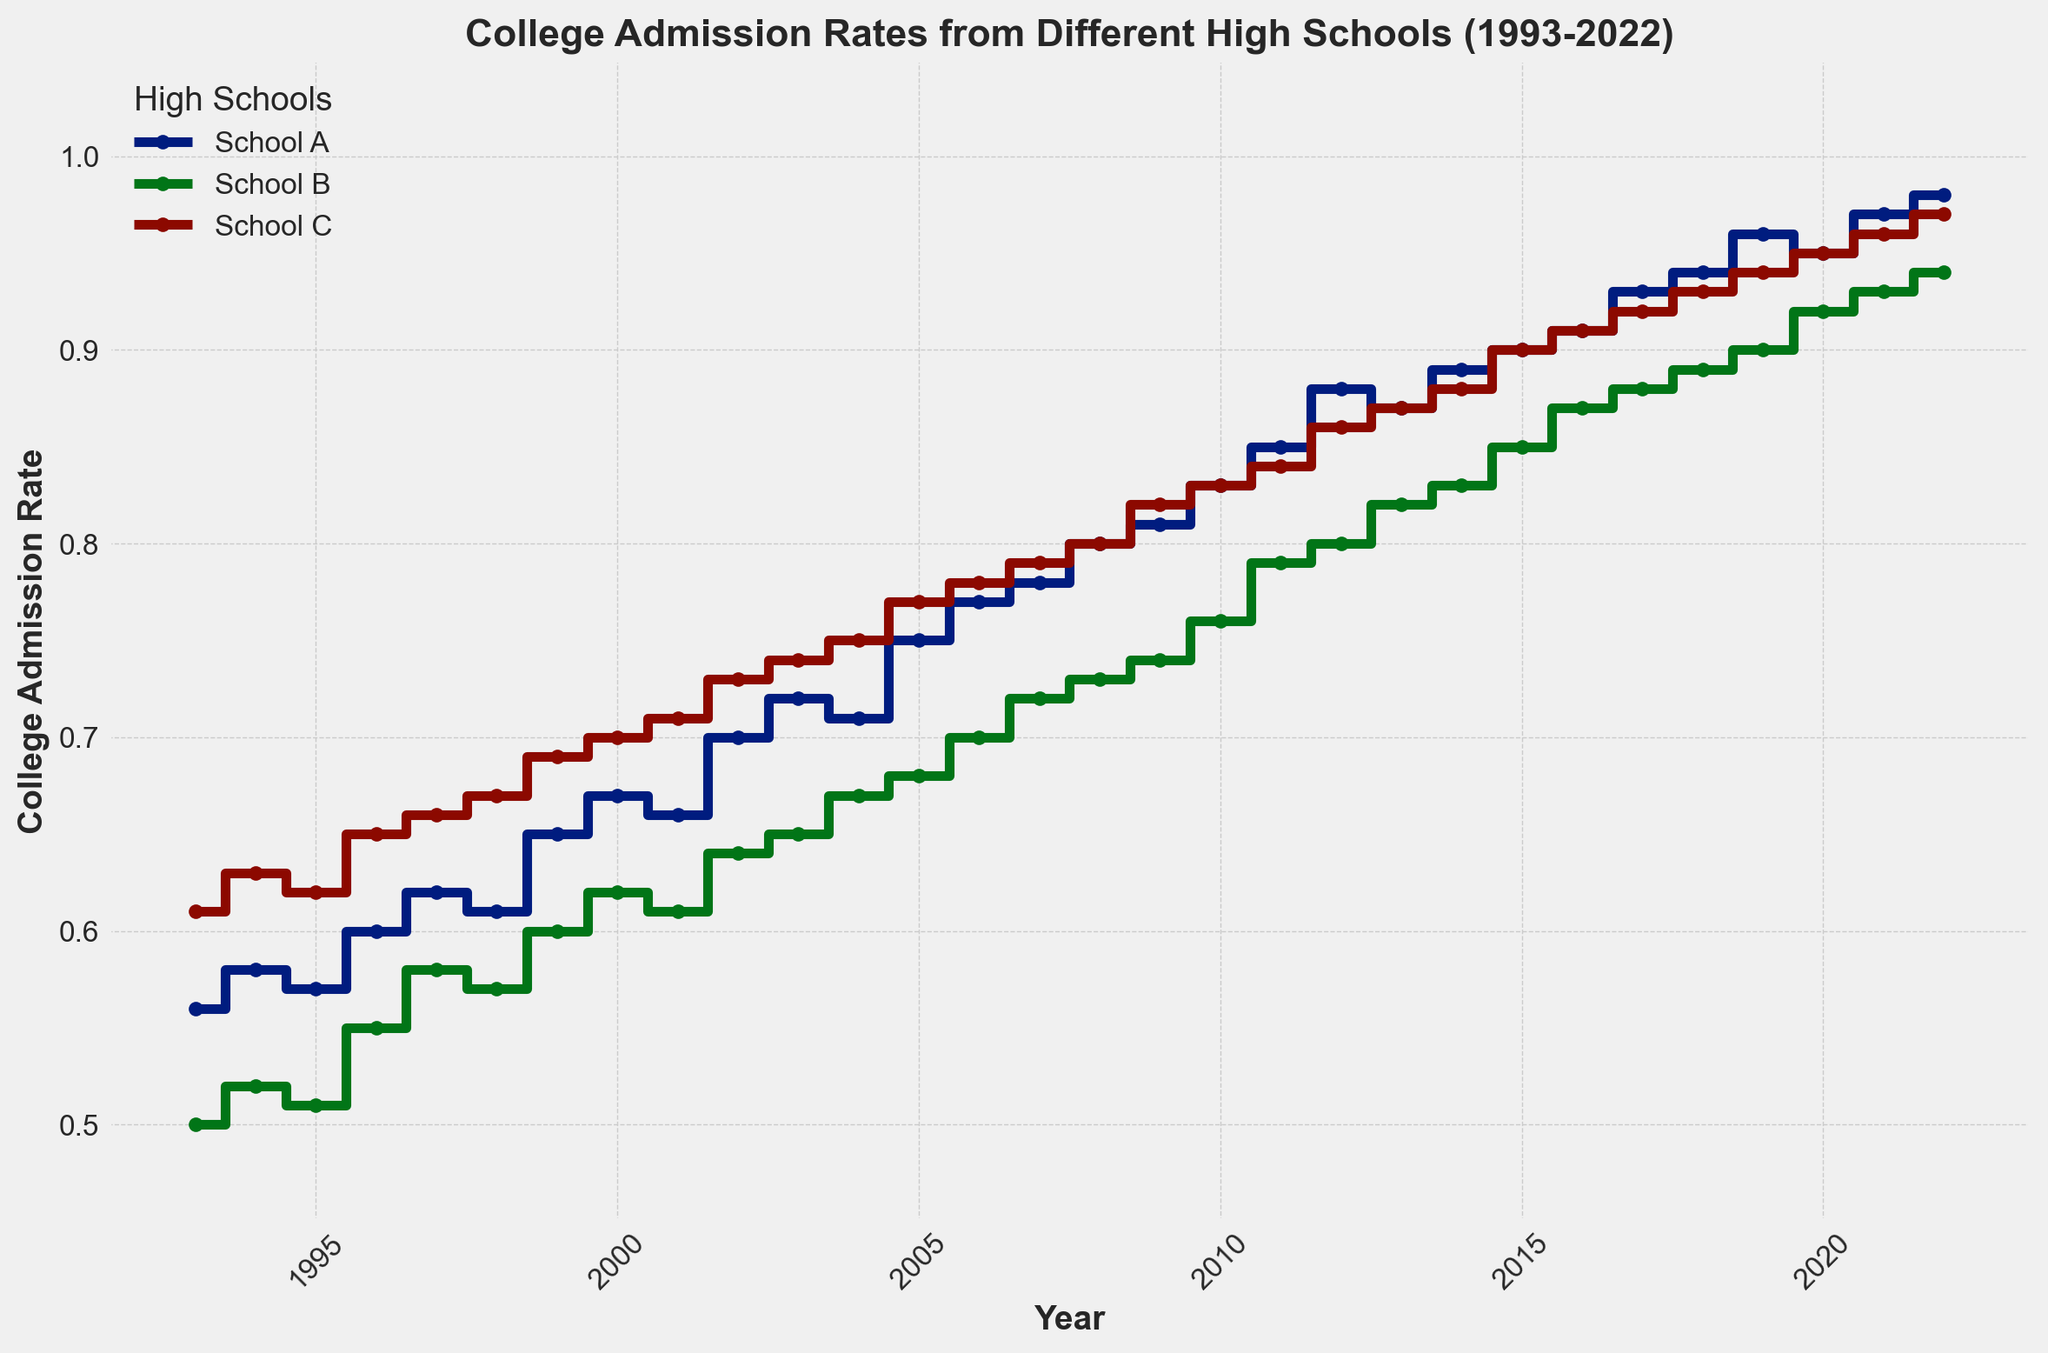What is the trend in college admission rates for High School A from 1993 to 2022? The figure shows a clear upward trend for High School A's college admission rates from 1993 to 2022, starting around 0.56 and rising to 0.98. The plot indicates a consistent increase over the years with some slight fluctuations.
Answer: Upward trend Which high school had the highest college admission rate in 2022? According to the figure, High School A had the highest college admission rate in 2022, reaching 0.98.
Answer: High School A By how much did the college admission rate for High School B increase from 1993 to 2022? To find the increase, subtract the admission rate in 1993 from the rate in 2022 for High School B. The rate in 1993 was 0.50, and in 2022 it was 0.94. Therefore, the increase is 0.94 - 0.50 = 0.44.
Answer: 0.44 How do the admission rates of High School C in 2000 compare to those of High School A in 2000? The plot shows that High School C had an admission rate of approximately 0.70 in 2000, while High School A had a rate of around 0.67 in the same year. High School C's rate was marginally higher.
Answer: High School C was slightly higher What is the average of the 2022 college admission rates for all three high schools? Add the 2022 admission rates for the three high schools and divide by 3. The rates are 0.98 (A), 0.94 (B), and 0.97 (C). The sum is 0.98 + 0.94 + 0.97 = 2.89, and the average is 2.89 / 3 ≈ 0.96.
Answer: ~0.96 Which high school showed the most significant single-year increase in college admission rates? To find the most significant single-year increase, examine the steepest steps in the plot. The steepest increase appears to be from 2001 to 2002 for High School A, where the rate jumped from 0.66 to 0.70, an increase of 0.04. However, further comparison could indicate other notable spikes.
Answer: High School A (2001 to 2002) Compare the admission rate trends of High School A and High School B over the first 10 years (1993-2002). In the first 10 years, both High School A and B show an upward trend. High School A starts at 0.56 and reaches 0.70, while High School B starts at 0.50 and reaches 0.64. Both schools have a consistent increase, but High School A's increase is slightly more substantial.
Answer: Both upward, High School A's increase is greater What color represents High School C in the plot? According to the figure, High School C is represented by a green line, making identification of C's data points visual.
Answer: Green 